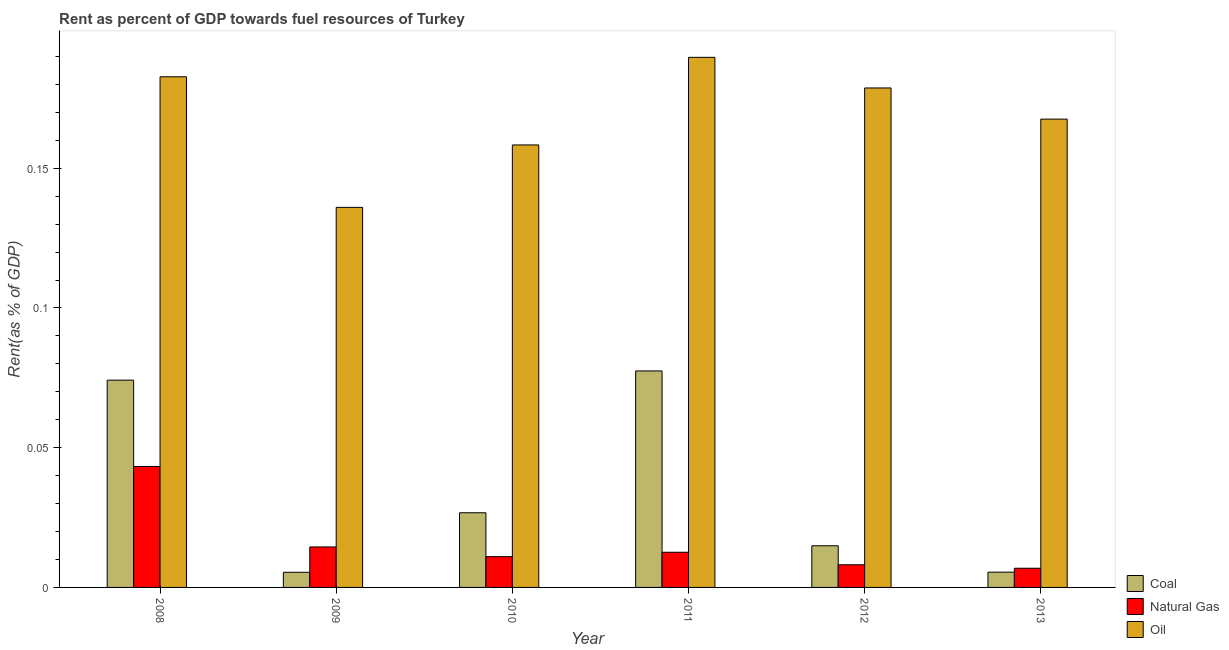How many different coloured bars are there?
Your response must be concise. 3. Are the number of bars on each tick of the X-axis equal?
Ensure brevity in your answer.  Yes. How many bars are there on the 2nd tick from the right?
Your answer should be very brief. 3. What is the label of the 4th group of bars from the left?
Ensure brevity in your answer.  2011. What is the rent towards natural gas in 2008?
Ensure brevity in your answer.  0.04. Across all years, what is the maximum rent towards natural gas?
Your answer should be compact. 0.04. Across all years, what is the minimum rent towards oil?
Give a very brief answer. 0.14. What is the total rent towards natural gas in the graph?
Give a very brief answer. 0.1. What is the difference between the rent towards coal in 2011 and that in 2013?
Your answer should be compact. 0.07. What is the difference between the rent towards coal in 2013 and the rent towards natural gas in 2011?
Your answer should be very brief. -0.07. What is the average rent towards oil per year?
Your answer should be compact. 0.17. In how many years, is the rent towards coal greater than 0.060000000000000005 %?
Your answer should be very brief. 2. What is the ratio of the rent towards coal in 2011 to that in 2013?
Your response must be concise. 14.19. Is the rent towards coal in 2009 less than that in 2012?
Your response must be concise. Yes. What is the difference between the highest and the second highest rent towards oil?
Your response must be concise. 0.01. What is the difference between the highest and the lowest rent towards coal?
Offer a very short reply. 0.07. In how many years, is the rent towards oil greater than the average rent towards oil taken over all years?
Provide a short and direct response. 3. Is the sum of the rent towards oil in 2009 and 2012 greater than the maximum rent towards coal across all years?
Keep it short and to the point. Yes. What does the 1st bar from the left in 2013 represents?
Provide a short and direct response. Coal. What does the 2nd bar from the right in 2013 represents?
Your answer should be compact. Natural Gas. Are all the bars in the graph horizontal?
Provide a succinct answer. No. What is the difference between two consecutive major ticks on the Y-axis?
Provide a short and direct response. 0.05. Does the graph contain grids?
Offer a very short reply. No. Where does the legend appear in the graph?
Provide a succinct answer. Bottom right. What is the title of the graph?
Your answer should be compact. Rent as percent of GDP towards fuel resources of Turkey. Does "Errors" appear as one of the legend labels in the graph?
Keep it short and to the point. No. What is the label or title of the X-axis?
Ensure brevity in your answer.  Year. What is the label or title of the Y-axis?
Offer a terse response. Rent(as % of GDP). What is the Rent(as % of GDP) in Coal in 2008?
Ensure brevity in your answer.  0.07. What is the Rent(as % of GDP) in Natural Gas in 2008?
Ensure brevity in your answer.  0.04. What is the Rent(as % of GDP) of Oil in 2008?
Provide a succinct answer. 0.18. What is the Rent(as % of GDP) in Coal in 2009?
Ensure brevity in your answer.  0.01. What is the Rent(as % of GDP) of Natural Gas in 2009?
Give a very brief answer. 0.01. What is the Rent(as % of GDP) of Oil in 2009?
Offer a terse response. 0.14. What is the Rent(as % of GDP) in Coal in 2010?
Your response must be concise. 0.03. What is the Rent(as % of GDP) of Natural Gas in 2010?
Provide a succinct answer. 0.01. What is the Rent(as % of GDP) of Oil in 2010?
Give a very brief answer. 0.16. What is the Rent(as % of GDP) of Coal in 2011?
Your answer should be compact. 0.08. What is the Rent(as % of GDP) in Natural Gas in 2011?
Give a very brief answer. 0.01. What is the Rent(as % of GDP) of Oil in 2011?
Give a very brief answer. 0.19. What is the Rent(as % of GDP) of Coal in 2012?
Offer a very short reply. 0.01. What is the Rent(as % of GDP) in Natural Gas in 2012?
Offer a very short reply. 0.01. What is the Rent(as % of GDP) in Oil in 2012?
Ensure brevity in your answer.  0.18. What is the Rent(as % of GDP) in Coal in 2013?
Provide a succinct answer. 0.01. What is the Rent(as % of GDP) of Natural Gas in 2013?
Your response must be concise. 0.01. What is the Rent(as % of GDP) in Oil in 2013?
Offer a terse response. 0.17. Across all years, what is the maximum Rent(as % of GDP) in Coal?
Your answer should be compact. 0.08. Across all years, what is the maximum Rent(as % of GDP) of Natural Gas?
Keep it short and to the point. 0.04. Across all years, what is the maximum Rent(as % of GDP) of Oil?
Offer a terse response. 0.19. Across all years, what is the minimum Rent(as % of GDP) in Coal?
Your response must be concise. 0.01. Across all years, what is the minimum Rent(as % of GDP) in Natural Gas?
Your response must be concise. 0.01. Across all years, what is the minimum Rent(as % of GDP) in Oil?
Your response must be concise. 0.14. What is the total Rent(as % of GDP) of Coal in the graph?
Make the answer very short. 0.2. What is the total Rent(as % of GDP) of Natural Gas in the graph?
Provide a succinct answer. 0.1. What is the total Rent(as % of GDP) of Oil in the graph?
Keep it short and to the point. 1.01. What is the difference between the Rent(as % of GDP) in Coal in 2008 and that in 2009?
Make the answer very short. 0.07. What is the difference between the Rent(as % of GDP) in Natural Gas in 2008 and that in 2009?
Your answer should be very brief. 0.03. What is the difference between the Rent(as % of GDP) in Oil in 2008 and that in 2009?
Give a very brief answer. 0.05. What is the difference between the Rent(as % of GDP) of Coal in 2008 and that in 2010?
Keep it short and to the point. 0.05. What is the difference between the Rent(as % of GDP) of Natural Gas in 2008 and that in 2010?
Your answer should be compact. 0.03. What is the difference between the Rent(as % of GDP) in Oil in 2008 and that in 2010?
Provide a short and direct response. 0.02. What is the difference between the Rent(as % of GDP) in Coal in 2008 and that in 2011?
Your response must be concise. -0. What is the difference between the Rent(as % of GDP) in Natural Gas in 2008 and that in 2011?
Ensure brevity in your answer.  0.03. What is the difference between the Rent(as % of GDP) of Oil in 2008 and that in 2011?
Make the answer very short. -0.01. What is the difference between the Rent(as % of GDP) of Coal in 2008 and that in 2012?
Offer a terse response. 0.06. What is the difference between the Rent(as % of GDP) of Natural Gas in 2008 and that in 2012?
Make the answer very short. 0.04. What is the difference between the Rent(as % of GDP) of Oil in 2008 and that in 2012?
Offer a terse response. 0. What is the difference between the Rent(as % of GDP) in Coal in 2008 and that in 2013?
Provide a succinct answer. 0.07. What is the difference between the Rent(as % of GDP) of Natural Gas in 2008 and that in 2013?
Keep it short and to the point. 0.04. What is the difference between the Rent(as % of GDP) in Oil in 2008 and that in 2013?
Provide a succinct answer. 0.02. What is the difference between the Rent(as % of GDP) in Coal in 2009 and that in 2010?
Ensure brevity in your answer.  -0.02. What is the difference between the Rent(as % of GDP) in Natural Gas in 2009 and that in 2010?
Your answer should be very brief. 0. What is the difference between the Rent(as % of GDP) of Oil in 2009 and that in 2010?
Give a very brief answer. -0.02. What is the difference between the Rent(as % of GDP) in Coal in 2009 and that in 2011?
Give a very brief answer. -0.07. What is the difference between the Rent(as % of GDP) in Natural Gas in 2009 and that in 2011?
Provide a short and direct response. 0. What is the difference between the Rent(as % of GDP) in Oil in 2009 and that in 2011?
Keep it short and to the point. -0.05. What is the difference between the Rent(as % of GDP) in Coal in 2009 and that in 2012?
Your answer should be very brief. -0.01. What is the difference between the Rent(as % of GDP) in Natural Gas in 2009 and that in 2012?
Provide a succinct answer. 0.01. What is the difference between the Rent(as % of GDP) of Oil in 2009 and that in 2012?
Your response must be concise. -0.04. What is the difference between the Rent(as % of GDP) of Coal in 2009 and that in 2013?
Ensure brevity in your answer.  -0. What is the difference between the Rent(as % of GDP) of Natural Gas in 2009 and that in 2013?
Offer a terse response. 0.01. What is the difference between the Rent(as % of GDP) in Oil in 2009 and that in 2013?
Make the answer very short. -0.03. What is the difference between the Rent(as % of GDP) of Coal in 2010 and that in 2011?
Your answer should be compact. -0.05. What is the difference between the Rent(as % of GDP) of Natural Gas in 2010 and that in 2011?
Make the answer very short. -0. What is the difference between the Rent(as % of GDP) in Oil in 2010 and that in 2011?
Provide a succinct answer. -0.03. What is the difference between the Rent(as % of GDP) in Coal in 2010 and that in 2012?
Offer a very short reply. 0.01. What is the difference between the Rent(as % of GDP) of Natural Gas in 2010 and that in 2012?
Your answer should be compact. 0. What is the difference between the Rent(as % of GDP) of Oil in 2010 and that in 2012?
Give a very brief answer. -0.02. What is the difference between the Rent(as % of GDP) in Coal in 2010 and that in 2013?
Provide a succinct answer. 0.02. What is the difference between the Rent(as % of GDP) of Natural Gas in 2010 and that in 2013?
Keep it short and to the point. 0. What is the difference between the Rent(as % of GDP) in Oil in 2010 and that in 2013?
Ensure brevity in your answer.  -0.01. What is the difference between the Rent(as % of GDP) of Coal in 2011 and that in 2012?
Make the answer very short. 0.06. What is the difference between the Rent(as % of GDP) of Natural Gas in 2011 and that in 2012?
Keep it short and to the point. 0. What is the difference between the Rent(as % of GDP) in Oil in 2011 and that in 2012?
Offer a terse response. 0.01. What is the difference between the Rent(as % of GDP) of Coal in 2011 and that in 2013?
Give a very brief answer. 0.07. What is the difference between the Rent(as % of GDP) in Natural Gas in 2011 and that in 2013?
Your answer should be compact. 0.01. What is the difference between the Rent(as % of GDP) in Oil in 2011 and that in 2013?
Your answer should be very brief. 0.02. What is the difference between the Rent(as % of GDP) in Coal in 2012 and that in 2013?
Keep it short and to the point. 0.01. What is the difference between the Rent(as % of GDP) in Natural Gas in 2012 and that in 2013?
Give a very brief answer. 0. What is the difference between the Rent(as % of GDP) of Oil in 2012 and that in 2013?
Provide a succinct answer. 0.01. What is the difference between the Rent(as % of GDP) of Coal in 2008 and the Rent(as % of GDP) of Natural Gas in 2009?
Offer a very short reply. 0.06. What is the difference between the Rent(as % of GDP) of Coal in 2008 and the Rent(as % of GDP) of Oil in 2009?
Give a very brief answer. -0.06. What is the difference between the Rent(as % of GDP) of Natural Gas in 2008 and the Rent(as % of GDP) of Oil in 2009?
Offer a terse response. -0.09. What is the difference between the Rent(as % of GDP) in Coal in 2008 and the Rent(as % of GDP) in Natural Gas in 2010?
Offer a terse response. 0.06. What is the difference between the Rent(as % of GDP) in Coal in 2008 and the Rent(as % of GDP) in Oil in 2010?
Give a very brief answer. -0.08. What is the difference between the Rent(as % of GDP) in Natural Gas in 2008 and the Rent(as % of GDP) in Oil in 2010?
Provide a succinct answer. -0.12. What is the difference between the Rent(as % of GDP) in Coal in 2008 and the Rent(as % of GDP) in Natural Gas in 2011?
Your answer should be very brief. 0.06. What is the difference between the Rent(as % of GDP) of Coal in 2008 and the Rent(as % of GDP) of Oil in 2011?
Your response must be concise. -0.12. What is the difference between the Rent(as % of GDP) in Natural Gas in 2008 and the Rent(as % of GDP) in Oil in 2011?
Provide a short and direct response. -0.15. What is the difference between the Rent(as % of GDP) of Coal in 2008 and the Rent(as % of GDP) of Natural Gas in 2012?
Offer a terse response. 0.07. What is the difference between the Rent(as % of GDP) of Coal in 2008 and the Rent(as % of GDP) of Oil in 2012?
Your response must be concise. -0.1. What is the difference between the Rent(as % of GDP) in Natural Gas in 2008 and the Rent(as % of GDP) in Oil in 2012?
Offer a very short reply. -0.14. What is the difference between the Rent(as % of GDP) in Coal in 2008 and the Rent(as % of GDP) in Natural Gas in 2013?
Ensure brevity in your answer.  0.07. What is the difference between the Rent(as % of GDP) in Coal in 2008 and the Rent(as % of GDP) in Oil in 2013?
Offer a terse response. -0.09. What is the difference between the Rent(as % of GDP) in Natural Gas in 2008 and the Rent(as % of GDP) in Oil in 2013?
Make the answer very short. -0.12. What is the difference between the Rent(as % of GDP) in Coal in 2009 and the Rent(as % of GDP) in Natural Gas in 2010?
Provide a short and direct response. -0.01. What is the difference between the Rent(as % of GDP) of Coal in 2009 and the Rent(as % of GDP) of Oil in 2010?
Give a very brief answer. -0.15. What is the difference between the Rent(as % of GDP) of Natural Gas in 2009 and the Rent(as % of GDP) of Oil in 2010?
Provide a succinct answer. -0.14. What is the difference between the Rent(as % of GDP) of Coal in 2009 and the Rent(as % of GDP) of Natural Gas in 2011?
Your response must be concise. -0.01. What is the difference between the Rent(as % of GDP) of Coal in 2009 and the Rent(as % of GDP) of Oil in 2011?
Your response must be concise. -0.18. What is the difference between the Rent(as % of GDP) of Natural Gas in 2009 and the Rent(as % of GDP) of Oil in 2011?
Your answer should be very brief. -0.18. What is the difference between the Rent(as % of GDP) in Coal in 2009 and the Rent(as % of GDP) in Natural Gas in 2012?
Provide a short and direct response. -0. What is the difference between the Rent(as % of GDP) in Coal in 2009 and the Rent(as % of GDP) in Oil in 2012?
Your response must be concise. -0.17. What is the difference between the Rent(as % of GDP) in Natural Gas in 2009 and the Rent(as % of GDP) in Oil in 2012?
Your answer should be very brief. -0.16. What is the difference between the Rent(as % of GDP) of Coal in 2009 and the Rent(as % of GDP) of Natural Gas in 2013?
Provide a short and direct response. -0. What is the difference between the Rent(as % of GDP) in Coal in 2009 and the Rent(as % of GDP) in Oil in 2013?
Offer a terse response. -0.16. What is the difference between the Rent(as % of GDP) in Natural Gas in 2009 and the Rent(as % of GDP) in Oil in 2013?
Keep it short and to the point. -0.15. What is the difference between the Rent(as % of GDP) in Coal in 2010 and the Rent(as % of GDP) in Natural Gas in 2011?
Offer a terse response. 0.01. What is the difference between the Rent(as % of GDP) of Coal in 2010 and the Rent(as % of GDP) of Oil in 2011?
Offer a terse response. -0.16. What is the difference between the Rent(as % of GDP) of Natural Gas in 2010 and the Rent(as % of GDP) of Oil in 2011?
Your response must be concise. -0.18. What is the difference between the Rent(as % of GDP) of Coal in 2010 and the Rent(as % of GDP) of Natural Gas in 2012?
Your answer should be compact. 0.02. What is the difference between the Rent(as % of GDP) of Coal in 2010 and the Rent(as % of GDP) of Oil in 2012?
Give a very brief answer. -0.15. What is the difference between the Rent(as % of GDP) of Natural Gas in 2010 and the Rent(as % of GDP) of Oil in 2012?
Provide a short and direct response. -0.17. What is the difference between the Rent(as % of GDP) in Coal in 2010 and the Rent(as % of GDP) in Natural Gas in 2013?
Keep it short and to the point. 0.02. What is the difference between the Rent(as % of GDP) of Coal in 2010 and the Rent(as % of GDP) of Oil in 2013?
Your answer should be compact. -0.14. What is the difference between the Rent(as % of GDP) in Natural Gas in 2010 and the Rent(as % of GDP) in Oil in 2013?
Ensure brevity in your answer.  -0.16. What is the difference between the Rent(as % of GDP) of Coal in 2011 and the Rent(as % of GDP) of Natural Gas in 2012?
Offer a terse response. 0.07. What is the difference between the Rent(as % of GDP) in Coal in 2011 and the Rent(as % of GDP) in Oil in 2012?
Keep it short and to the point. -0.1. What is the difference between the Rent(as % of GDP) in Natural Gas in 2011 and the Rent(as % of GDP) in Oil in 2012?
Keep it short and to the point. -0.17. What is the difference between the Rent(as % of GDP) of Coal in 2011 and the Rent(as % of GDP) of Natural Gas in 2013?
Give a very brief answer. 0.07. What is the difference between the Rent(as % of GDP) of Coal in 2011 and the Rent(as % of GDP) of Oil in 2013?
Your response must be concise. -0.09. What is the difference between the Rent(as % of GDP) in Natural Gas in 2011 and the Rent(as % of GDP) in Oil in 2013?
Make the answer very short. -0.15. What is the difference between the Rent(as % of GDP) of Coal in 2012 and the Rent(as % of GDP) of Natural Gas in 2013?
Keep it short and to the point. 0.01. What is the difference between the Rent(as % of GDP) in Coal in 2012 and the Rent(as % of GDP) in Oil in 2013?
Offer a terse response. -0.15. What is the difference between the Rent(as % of GDP) in Natural Gas in 2012 and the Rent(as % of GDP) in Oil in 2013?
Make the answer very short. -0.16. What is the average Rent(as % of GDP) in Coal per year?
Your answer should be very brief. 0.03. What is the average Rent(as % of GDP) of Natural Gas per year?
Provide a short and direct response. 0.02. What is the average Rent(as % of GDP) of Oil per year?
Your answer should be very brief. 0.17. In the year 2008, what is the difference between the Rent(as % of GDP) in Coal and Rent(as % of GDP) in Natural Gas?
Provide a succinct answer. 0.03. In the year 2008, what is the difference between the Rent(as % of GDP) in Coal and Rent(as % of GDP) in Oil?
Make the answer very short. -0.11. In the year 2008, what is the difference between the Rent(as % of GDP) in Natural Gas and Rent(as % of GDP) in Oil?
Offer a terse response. -0.14. In the year 2009, what is the difference between the Rent(as % of GDP) of Coal and Rent(as % of GDP) of Natural Gas?
Offer a terse response. -0.01. In the year 2009, what is the difference between the Rent(as % of GDP) in Coal and Rent(as % of GDP) in Oil?
Keep it short and to the point. -0.13. In the year 2009, what is the difference between the Rent(as % of GDP) in Natural Gas and Rent(as % of GDP) in Oil?
Your answer should be compact. -0.12. In the year 2010, what is the difference between the Rent(as % of GDP) in Coal and Rent(as % of GDP) in Natural Gas?
Make the answer very short. 0.02. In the year 2010, what is the difference between the Rent(as % of GDP) of Coal and Rent(as % of GDP) of Oil?
Your answer should be very brief. -0.13. In the year 2010, what is the difference between the Rent(as % of GDP) in Natural Gas and Rent(as % of GDP) in Oil?
Ensure brevity in your answer.  -0.15. In the year 2011, what is the difference between the Rent(as % of GDP) of Coal and Rent(as % of GDP) of Natural Gas?
Your response must be concise. 0.06. In the year 2011, what is the difference between the Rent(as % of GDP) of Coal and Rent(as % of GDP) of Oil?
Provide a succinct answer. -0.11. In the year 2011, what is the difference between the Rent(as % of GDP) in Natural Gas and Rent(as % of GDP) in Oil?
Offer a very short reply. -0.18. In the year 2012, what is the difference between the Rent(as % of GDP) in Coal and Rent(as % of GDP) in Natural Gas?
Your response must be concise. 0.01. In the year 2012, what is the difference between the Rent(as % of GDP) of Coal and Rent(as % of GDP) of Oil?
Your answer should be very brief. -0.16. In the year 2012, what is the difference between the Rent(as % of GDP) of Natural Gas and Rent(as % of GDP) of Oil?
Your response must be concise. -0.17. In the year 2013, what is the difference between the Rent(as % of GDP) in Coal and Rent(as % of GDP) in Natural Gas?
Provide a short and direct response. -0. In the year 2013, what is the difference between the Rent(as % of GDP) of Coal and Rent(as % of GDP) of Oil?
Give a very brief answer. -0.16. In the year 2013, what is the difference between the Rent(as % of GDP) of Natural Gas and Rent(as % of GDP) of Oil?
Ensure brevity in your answer.  -0.16. What is the ratio of the Rent(as % of GDP) in Coal in 2008 to that in 2009?
Offer a very short reply. 13.69. What is the ratio of the Rent(as % of GDP) in Natural Gas in 2008 to that in 2009?
Keep it short and to the point. 2.99. What is the ratio of the Rent(as % of GDP) in Oil in 2008 to that in 2009?
Provide a short and direct response. 1.34. What is the ratio of the Rent(as % of GDP) of Coal in 2008 to that in 2010?
Provide a succinct answer. 2.78. What is the ratio of the Rent(as % of GDP) of Natural Gas in 2008 to that in 2010?
Make the answer very short. 3.93. What is the ratio of the Rent(as % of GDP) of Oil in 2008 to that in 2010?
Provide a short and direct response. 1.15. What is the ratio of the Rent(as % of GDP) of Coal in 2008 to that in 2011?
Give a very brief answer. 0.96. What is the ratio of the Rent(as % of GDP) in Natural Gas in 2008 to that in 2011?
Offer a very short reply. 3.44. What is the ratio of the Rent(as % of GDP) of Oil in 2008 to that in 2011?
Give a very brief answer. 0.96. What is the ratio of the Rent(as % of GDP) of Coal in 2008 to that in 2012?
Offer a terse response. 4.98. What is the ratio of the Rent(as % of GDP) of Natural Gas in 2008 to that in 2012?
Give a very brief answer. 5.34. What is the ratio of the Rent(as % of GDP) in Oil in 2008 to that in 2012?
Your answer should be very brief. 1.02. What is the ratio of the Rent(as % of GDP) in Coal in 2008 to that in 2013?
Offer a terse response. 13.58. What is the ratio of the Rent(as % of GDP) in Natural Gas in 2008 to that in 2013?
Ensure brevity in your answer.  6.3. What is the ratio of the Rent(as % of GDP) of Oil in 2008 to that in 2013?
Your response must be concise. 1.09. What is the ratio of the Rent(as % of GDP) in Coal in 2009 to that in 2010?
Make the answer very short. 0.2. What is the ratio of the Rent(as % of GDP) of Natural Gas in 2009 to that in 2010?
Your response must be concise. 1.31. What is the ratio of the Rent(as % of GDP) of Oil in 2009 to that in 2010?
Offer a terse response. 0.86. What is the ratio of the Rent(as % of GDP) of Coal in 2009 to that in 2011?
Keep it short and to the point. 0.07. What is the ratio of the Rent(as % of GDP) in Natural Gas in 2009 to that in 2011?
Make the answer very short. 1.15. What is the ratio of the Rent(as % of GDP) in Oil in 2009 to that in 2011?
Make the answer very short. 0.72. What is the ratio of the Rent(as % of GDP) in Coal in 2009 to that in 2012?
Give a very brief answer. 0.36. What is the ratio of the Rent(as % of GDP) of Natural Gas in 2009 to that in 2012?
Provide a succinct answer. 1.79. What is the ratio of the Rent(as % of GDP) in Oil in 2009 to that in 2012?
Your response must be concise. 0.76. What is the ratio of the Rent(as % of GDP) of Natural Gas in 2009 to that in 2013?
Offer a terse response. 2.11. What is the ratio of the Rent(as % of GDP) in Oil in 2009 to that in 2013?
Keep it short and to the point. 0.81. What is the ratio of the Rent(as % of GDP) in Coal in 2010 to that in 2011?
Offer a very short reply. 0.34. What is the ratio of the Rent(as % of GDP) in Natural Gas in 2010 to that in 2011?
Your answer should be compact. 0.88. What is the ratio of the Rent(as % of GDP) of Oil in 2010 to that in 2011?
Your answer should be compact. 0.83. What is the ratio of the Rent(as % of GDP) in Coal in 2010 to that in 2012?
Your answer should be very brief. 1.79. What is the ratio of the Rent(as % of GDP) in Natural Gas in 2010 to that in 2012?
Offer a terse response. 1.36. What is the ratio of the Rent(as % of GDP) of Oil in 2010 to that in 2012?
Give a very brief answer. 0.89. What is the ratio of the Rent(as % of GDP) in Coal in 2010 to that in 2013?
Offer a very short reply. 4.89. What is the ratio of the Rent(as % of GDP) in Natural Gas in 2010 to that in 2013?
Your response must be concise. 1.6. What is the ratio of the Rent(as % of GDP) in Oil in 2010 to that in 2013?
Provide a short and direct response. 0.94. What is the ratio of the Rent(as % of GDP) of Coal in 2011 to that in 2012?
Your response must be concise. 5.2. What is the ratio of the Rent(as % of GDP) in Natural Gas in 2011 to that in 2012?
Offer a very short reply. 1.55. What is the ratio of the Rent(as % of GDP) in Oil in 2011 to that in 2012?
Offer a terse response. 1.06. What is the ratio of the Rent(as % of GDP) of Coal in 2011 to that in 2013?
Provide a succinct answer. 14.19. What is the ratio of the Rent(as % of GDP) of Natural Gas in 2011 to that in 2013?
Offer a terse response. 1.83. What is the ratio of the Rent(as % of GDP) in Oil in 2011 to that in 2013?
Give a very brief answer. 1.13. What is the ratio of the Rent(as % of GDP) in Coal in 2012 to that in 2013?
Provide a short and direct response. 2.73. What is the ratio of the Rent(as % of GDP) in Natural Gas in 2012 to that in 2013?
Make the answer very short. 1.18. What is the ratio of the Rent(as % of GDP) in Oil in 2012 to that in 2013?
Ensure brevity in your answer.  1.07. What is the difference between the highest and the second highest Rent(as % of GDP) of Coal?
Give a very brief answer. 0. What is the difference between the highest and the second highest Rent(as % of GDP) in Natural Gas?
Your response must be concise. 0.03. What is the difference between the highest and the second highest Rent(as % of GDP) in Oil?
Give a very brief answer. 0.01. What is the difference between the highest and the lowest Rent(as % of GDP) in Coal?
Make the answer very short. 0.07. What is the difference between the highest and the lowest Rent(as % of GDP) of Natural Gas?
Provide a succinct answer. 0.04. What is the difference between the highest and the lowest Rent(as % of GDP) in Oil?
Your response must be concise. 0.05. 